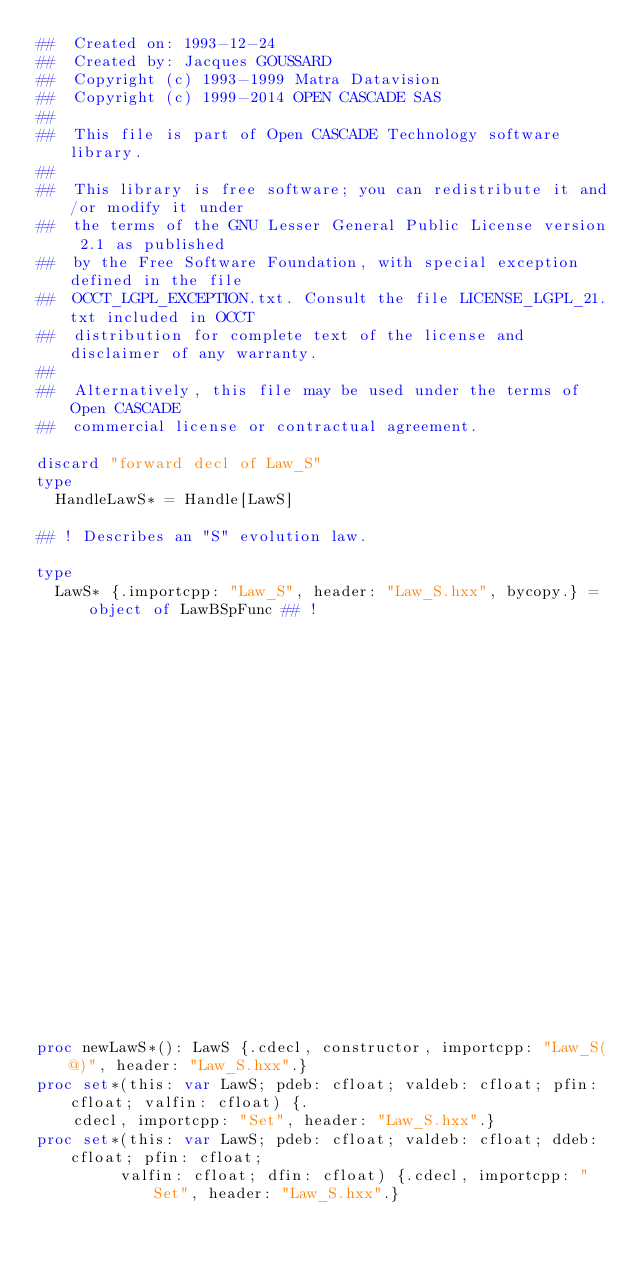Convert code to text. <code><loc_0><loc_0><loc_500><loc_500><_Nim_>##  Created on: 1993-12-24
##  Created by: Jacques GOUSSARD
##  Copyright (c) 1993-1999 Matra Datavision
##  Copyright (c) 1999-2014 OPEN CASCADE SAS
##
##  This file is part of Open CASCADE Technology software library.
##
##  This library is free software; you can redistribute it and/or modify it under
##  the terms of the GNU Lesser General Public License version 2.1 as published
##  by the Free Software Foundation, with special exception defined in the file
##  OCCT_LGPL_EXCEPTION.txt. Consult the file LICENSE_LGPL_21.txt included in OCCT
##  distribution for complete text of the license and disclaimer of any warranty.
##
##  Alternatively, this file may be used under the terms of Open CASCADE
##  commercial license or contractual agreement.

discard "forward decl of Law_S"
type
  HandleLawS* = Handle[LawS]

## ! Describes an "S" evolution law.

type
  LawS* {.importcpp: "Law_S", header: "Law_S.hxx", bycopy.} = object of LawBSpFunc ## !
                                                                         ## Constructs an empty "S"
                                                                         ## evolution law.


proc newLawS*(): LawS {.cdecl, constructor, importcpp: "Law_S(@)", header: "Law_S.hxx".}
proc set*(this: var LawS; pdeb: cfloat; valdeb: cfloat; pfin: cfloat; valfin: cfloat) {.
    cdecl, importcpp: "Set", header: "Law_S.hxx".}
proc set*(this: var LawS; pdeb: cfloat; valdeb: cfloat; ddeb: cfloat; pfin: cfloat;
         valfin: cfloat; dfin: cfloat) {.cdecl, importcpp: "Set", header: "Law_S.hxx".}</code> 